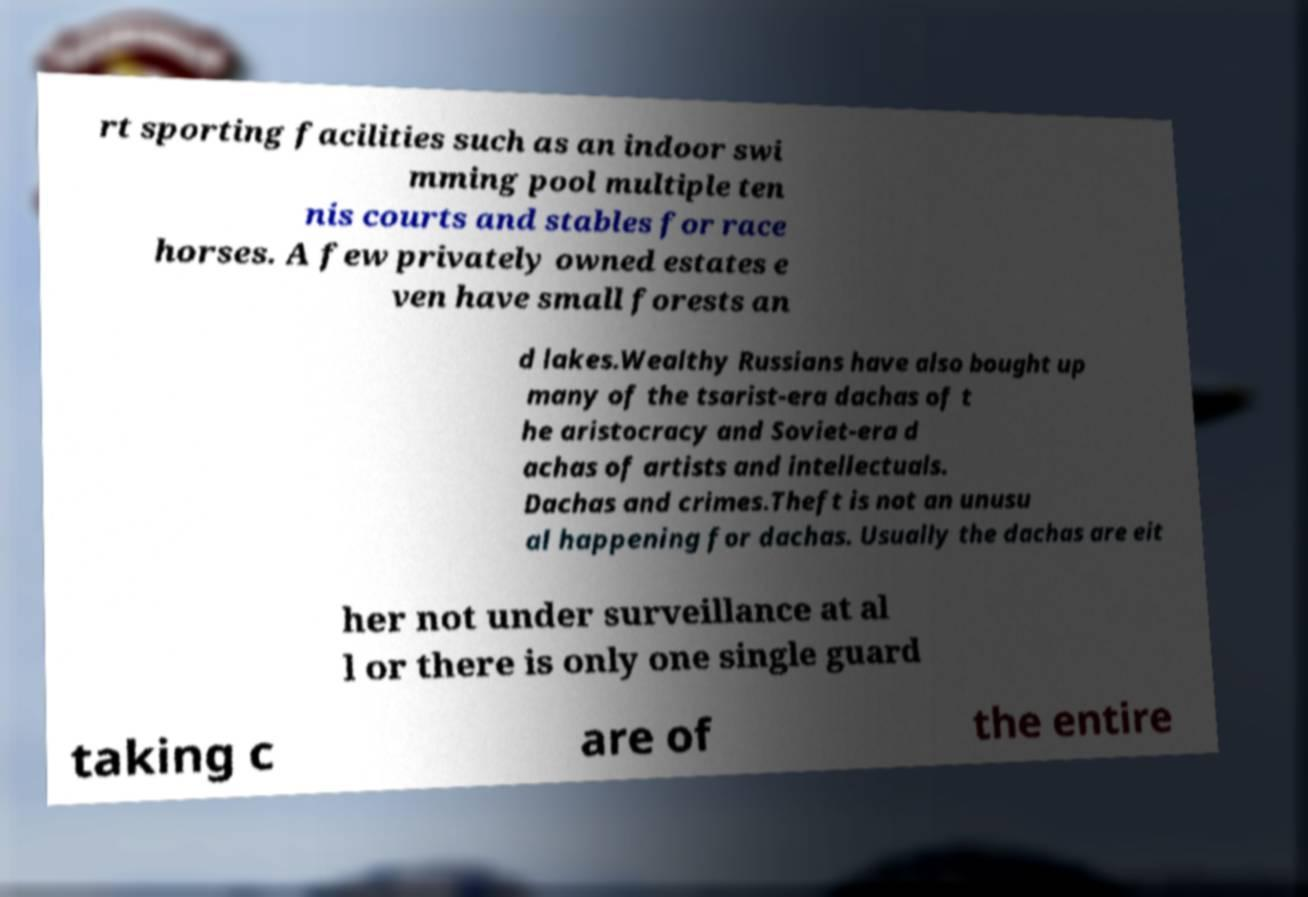There's text embedded in this image that I need extracted. Can you transcribe it verbatim? rt sporting facilities such as an indoor swi mming pool multiple ten nis courts and stables for race horses. A few privately owned estates e ven have small forests an d lakes.Wealthy Russians have also bought up many of the tsarist-era dachas of t he aristocracy and Soviet-era d achas of artists and intellectuals. Dachas and crimes.Theft is not an unusu al happening for dachas. Usually the dachas are eit her not under surveillance at al l or there is only one single guard taking c are of the entire 